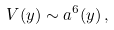<formula> <loc_0><loc_0><loc_500><loc_500>V ( y ) \sim a ^ { 6 } ( y ) \, ,</formula> 